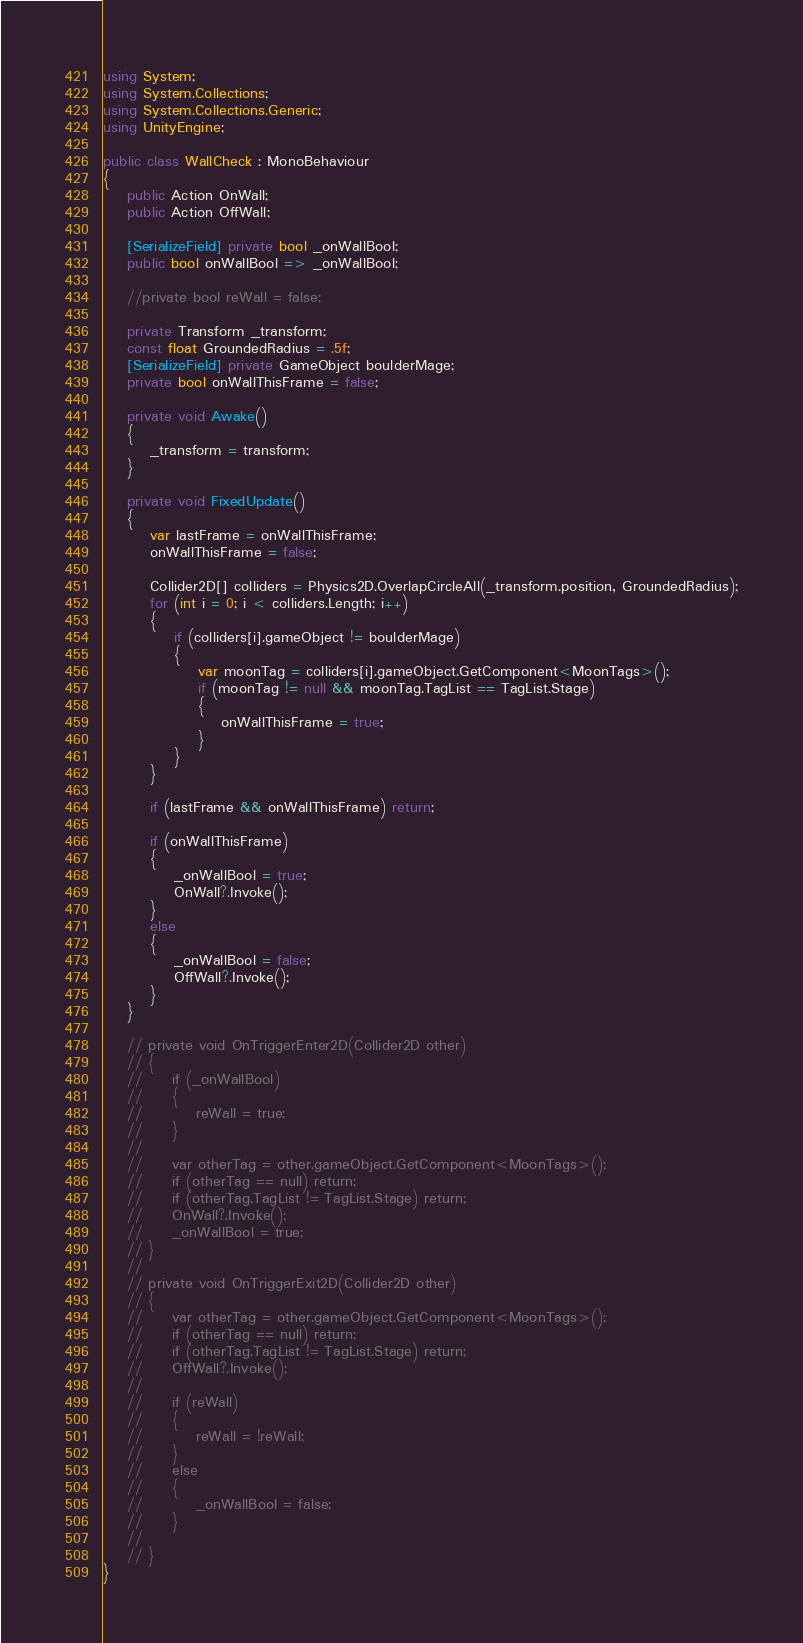<code> <loc_0><loc_0><loc_500><loc_500><_C#_>using System;
using System.Collections;
using System.Collections.Generic;
using UnityEngine;

public class WallCheck : MonoBehaviour
{
    public Action OnWall;
    public Action OffWall;

    [SerializeField] private bool _onWallBool;
    public bool onWallBool => _onWallBool;
    
    //private bool reWall = false;
    
    private Transform _transform;
    const float GroundedRadius = .5f;
    [SerializeField] private GameObject boulderMage;
    private bool onWallThisFrame = false;

    private void Awake()
    {
        _transform = transform;
    }
    
    private void FixedUpdate()
    {
        var lastFrame = onWallThisFrame;
        onWallThisFrame = false;
        
        Collider2D[] colliders = Physics2D.OverlapCircleAll(_transform.position, GroundedRadius);
        for (int i = 0; i < colliders.Length; i++)
        {
            if (colliders[i].gameObject != boulderMage)
            {
                var moonTag = colliders[i].gameObject.GetComponent<MoonTags>();
                if (moonTag != null && moonTag.TagList == TagList.Stage)
                {
                    onWallThisFrame = true;
                }
            }
        }
        
        if (lastFrame && onWallThisFrame) return;

        if (onWallThisFrame)
        {
            _onWallBool = true;
            OnWall?.Invoke();
        }
        else
        {
            _onWallBool = false;
            OffWall?.Invoke();
        }
    }

    // private void OnTriggerEnter2D(Collider2D other)
    // {
    //     if (_onWallBool)
    //     {
    //         reWall = true;
    //     }
    //     
    //     var otherTag = other.gameObject.GetComponent<MoonTags>();
    //     if (otherTag == null) return;
    //     if (otherTag.TagList != TagList.Stage) return;
    //     OnWall?.Invoke();
    //     _onWallBool = true;
    // }
    //
    // private void OnTriggerExit2D(Collider2D other)
    // {
    //     var otherTag = other.gameObject.GetComponent<MoonTags>();
    //     if (otherTag == null) return;
    //     if (otherTag.TagList != TagList.Stage) return;
    //     OffWall?.Invoke();
    //     
    //     if (reWall)
    //     {
    //         reWall = !reWall;
    //     }
    //     else
    //     {
    //         _onWallBool = false;
    //     }
    //     
    // }
}
</code> 